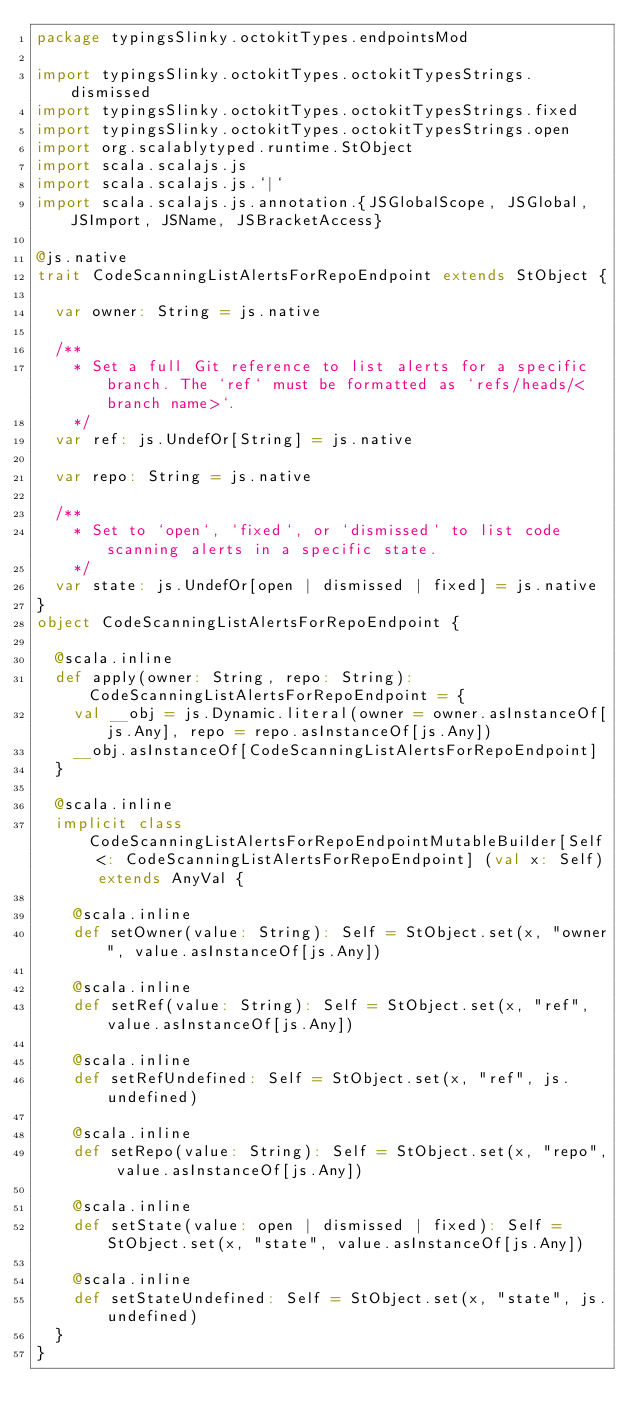Convert code to text. <code><loc_0><loc_0><loc_500><loc_500><_Scala_>package typingsSlinky.octokitTypes.endpointsMod

import typingsSlinky.octokitTypes.octokitTypesStrings.dismissed
import typingsSlinky.octokitTypes.octokitTypesStrings.fixed
import typingsSlinky.octokitTypes.octokitTypesStrings.open
import org.scalablytyped.runtime.StObject
import scala.scalajs.js
import scala.scalajs.js.`|`
import scala.scalajs.js.annotation.{JSGlobalScope, JSGlobal, JSImport, JSName, JSBracketAccess}

@js.native
trait CodeScanningListAlertsForRepoEndpoint extends StObject {
  
  var owner: String = js.native
  
  /**
    * Set a full Git reference to list alerts for a specific branch. The `ref` must be formatted as `refs/heads/<branch name>`.
    */
  var ref: js.UndefOr[String] = js.native
  
  var repo: String = js.native
  
  /**
    * Set to `open`, `fixed`, or `dismissed` to list code scanning alerts in a specific state.
    */
  var state: js.UndefOr[open | dismissed | fixed] = js.native
}
object CodeScanningListAlertsForRepoEndpoint {
  
  @scala.inline
  def apply(owner: String, repo: String): CodeScanningListAlertsForRepoEndpoint = {
    val __obj = js.Dynamic.literal(owner = owner.asInstanceOf[js.Any], repo = repo.asInstanceOf[js.Any])
    __obj.asInstanceOf[CodeScanningListAlertsForRepoEndpoint]
  }
  
  @scala.inline
  implicit class CodeScanningListAlertsForRepoEndpointMutableBuilder[Self <: CodeScanningListAlertsForRepoEndpoint] (val x: Self) extends AnyVal {
    
    @scala.inline
    def setOwner(value: String): Self = StObject.set(x, "owner", value.asInstanceOf[js.Any])
    
    @scala.inline
    def setRef(value: String): Self = StObject.set(x, "ref", value.asInstanceOf[js.Any])
    
    @scala.inline
    def setRefUndefined: Self = StObject.set(x, "ref", js.undefined)
    
    @scala.inline
    def setRepo(value: String): Self = StObject.set(x, "repo", value.asInstanceOf[js.Any])
    
    @scala.inline
    def setState(value: open | dismissed | fixed): Self = StObject.set(x, "state", value.asInstanceOf[js.Any])
    
    @scala.inline
    def setStateUndefined: Self = StObject.set(x, "state", js.undefined)
  }
}
</code> 